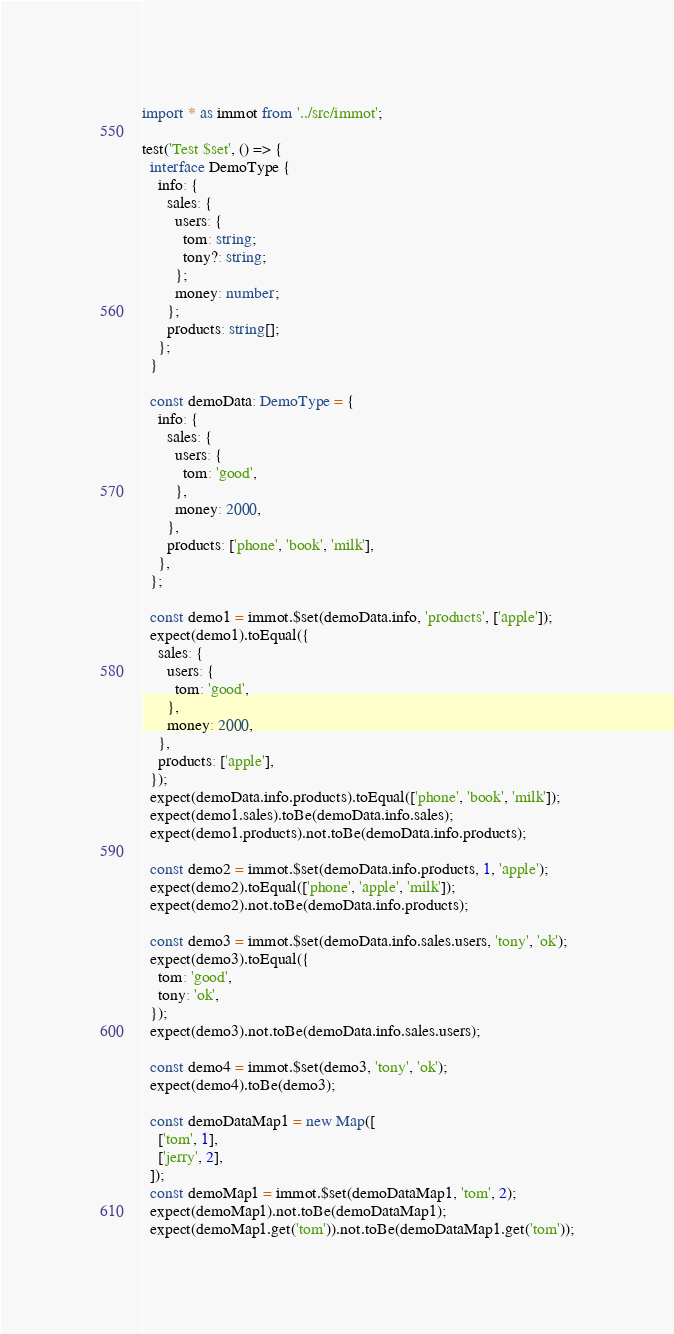Convert code to text. <code><loc_0><loc_0><loc_500><loc_500><_TypeScript_>import * as immot from '../src/immot';

test('Test $set', () => {
  interface DemoType {
    info: {
      sales: {
        users: {
          tom: string;
          tony?: string;
        };
        money: number;
      };
      products: string[];
    };
  }

  const demoData: DemoType = {
    info: {
      sales: {
        users: {
          tom: 'good',
        },
        money: 2000,
      },
      products: ['phone', 'book', 'milk'],
    },
  };

  const demo1 = immot.$set(demoData.info, 'products', ['apple']);
  expect(demo1).toEqual({
    sales: {
      users: {
        tom: 'good',
      },
      money: 2000,
    },
    products: ['apple'],
  });
  expect(demoData.info.products).toEqual(['phone', 'book', 'milk']);
  expect(demo1.sales).toBe(demoData.info.sales);
  expect(demo1.products).not.toBe(demoData.info.products);

  const demo2 = immot.$set(demoData.info.products, 1, 'apple');
  expect(demo2).toEqual(['phone', 'apple', 'milk']);
  expect(demo2).not.toBe(demoData.info.products);

  const demo3 = immot.$set(demoData.info.sales.users, 'tony', 'ok');
  expect(demo3).toEqual({
    tom: 'good',
    tony: 'ok',
  });
  expect(demo3).not.toBe(demoData.info.sales.users);

  const demo4 = immot.$set(demo3, 'tony', 'ok');
  expect(demo4).toBe(demo3);

  const demoDataMap1 = new Map([
    ['tom', 1],
    ['jerry', 2],
  ]);
  const demoMap1 = immot.$set(demoDataMap1, 'tom', 2);
  expect(demoMap1).not.toBe(demoDataMap1);
  expect(demoMap1.get('tom')).not.toBe(demoDataMap1.get('tom'));</code> 